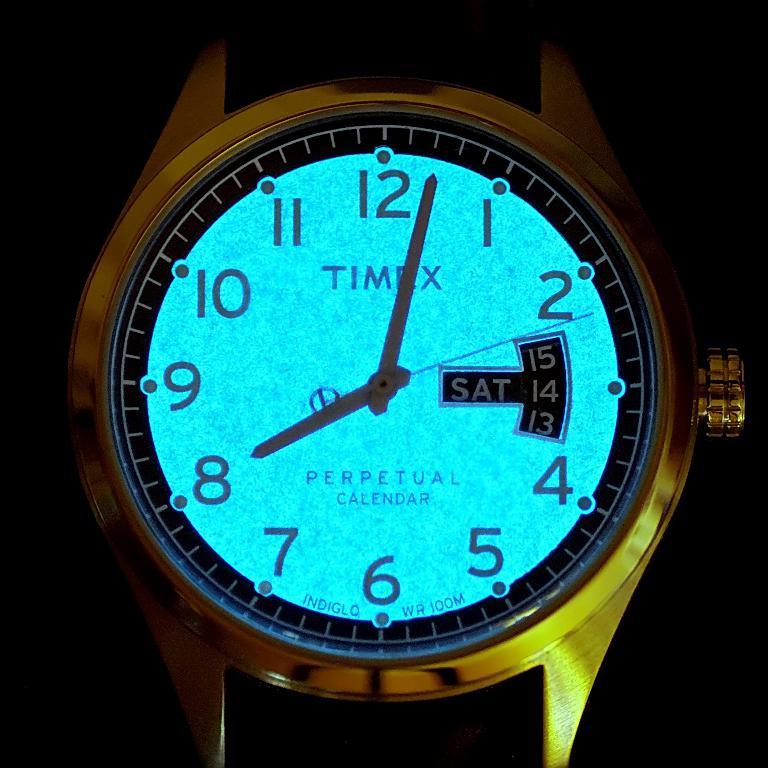What day is it?
Provide a succinct answer. Saturday. Who makes this watch?
Provide a succinct answer. Timex. 